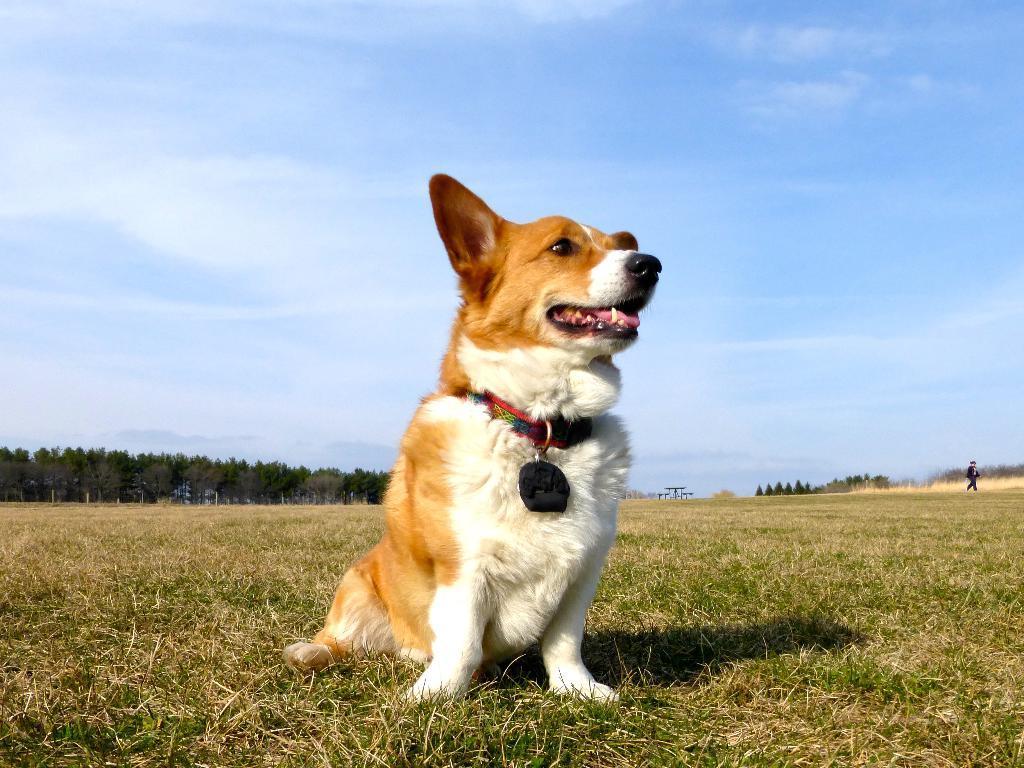How would you summarize this image in a sentence or two? In this image there is a dog sitting on the ground. In the background there are trees. At the top there is the sky. 